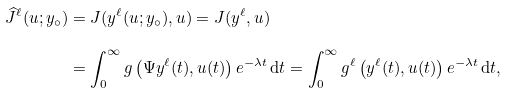<formula> <loc_0><loc_0><loc_500><loc_500>\widehat { J } ^ { \ell } ( u ; y _ { \circ } ) & = J ( y ^ { \ell } ( u ; y _ { \circ } ) , u ) = J ( y ^ { \ell } , u ) \\ & = \int _ { 0 } ^ { \infty } g \left ( \Psi y ^ { \ell } ( t ) , u ( t ) \right ) e ^ { - \lambda t } \, \mathrm d t = \int _ { 0 } ^ { \infty } g ^ { \ell } \left ( y ^ { \ell } ( t ) , u ( t ) \right ) e ^ { - \lambda t } \, \mathrm d t ,</formula> 